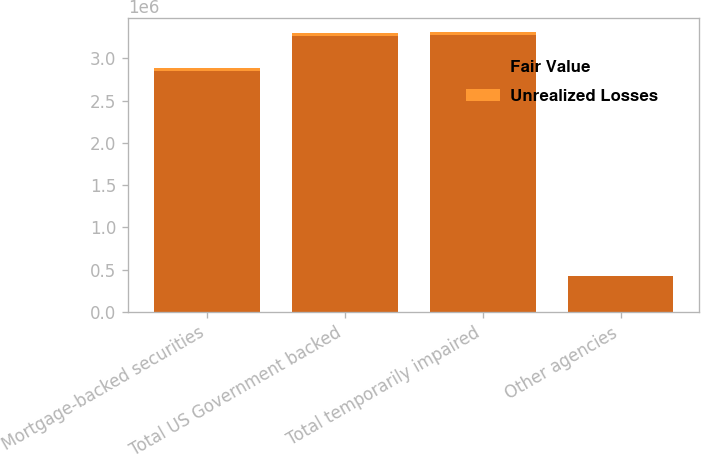Convert chart to OTSL. <chart><loc_0><loc_0><loc_500><loc_500><stacked_bar_chart><ecel><fcel>Mortgage-backed securities<fcel>Total US Government backed<fcel>Total temporarily impaired<fcel>Other agencies<nl><fcel>Fair Value<fcel>2.85536e+06<fcel>3.26857e+06<fcel>3.27447e+06<fcel>425410<nl><fcel>Unrealized Losses<fcel>31470<fcel>34952<fcel>35221<fcel>2689<nl></chart> 